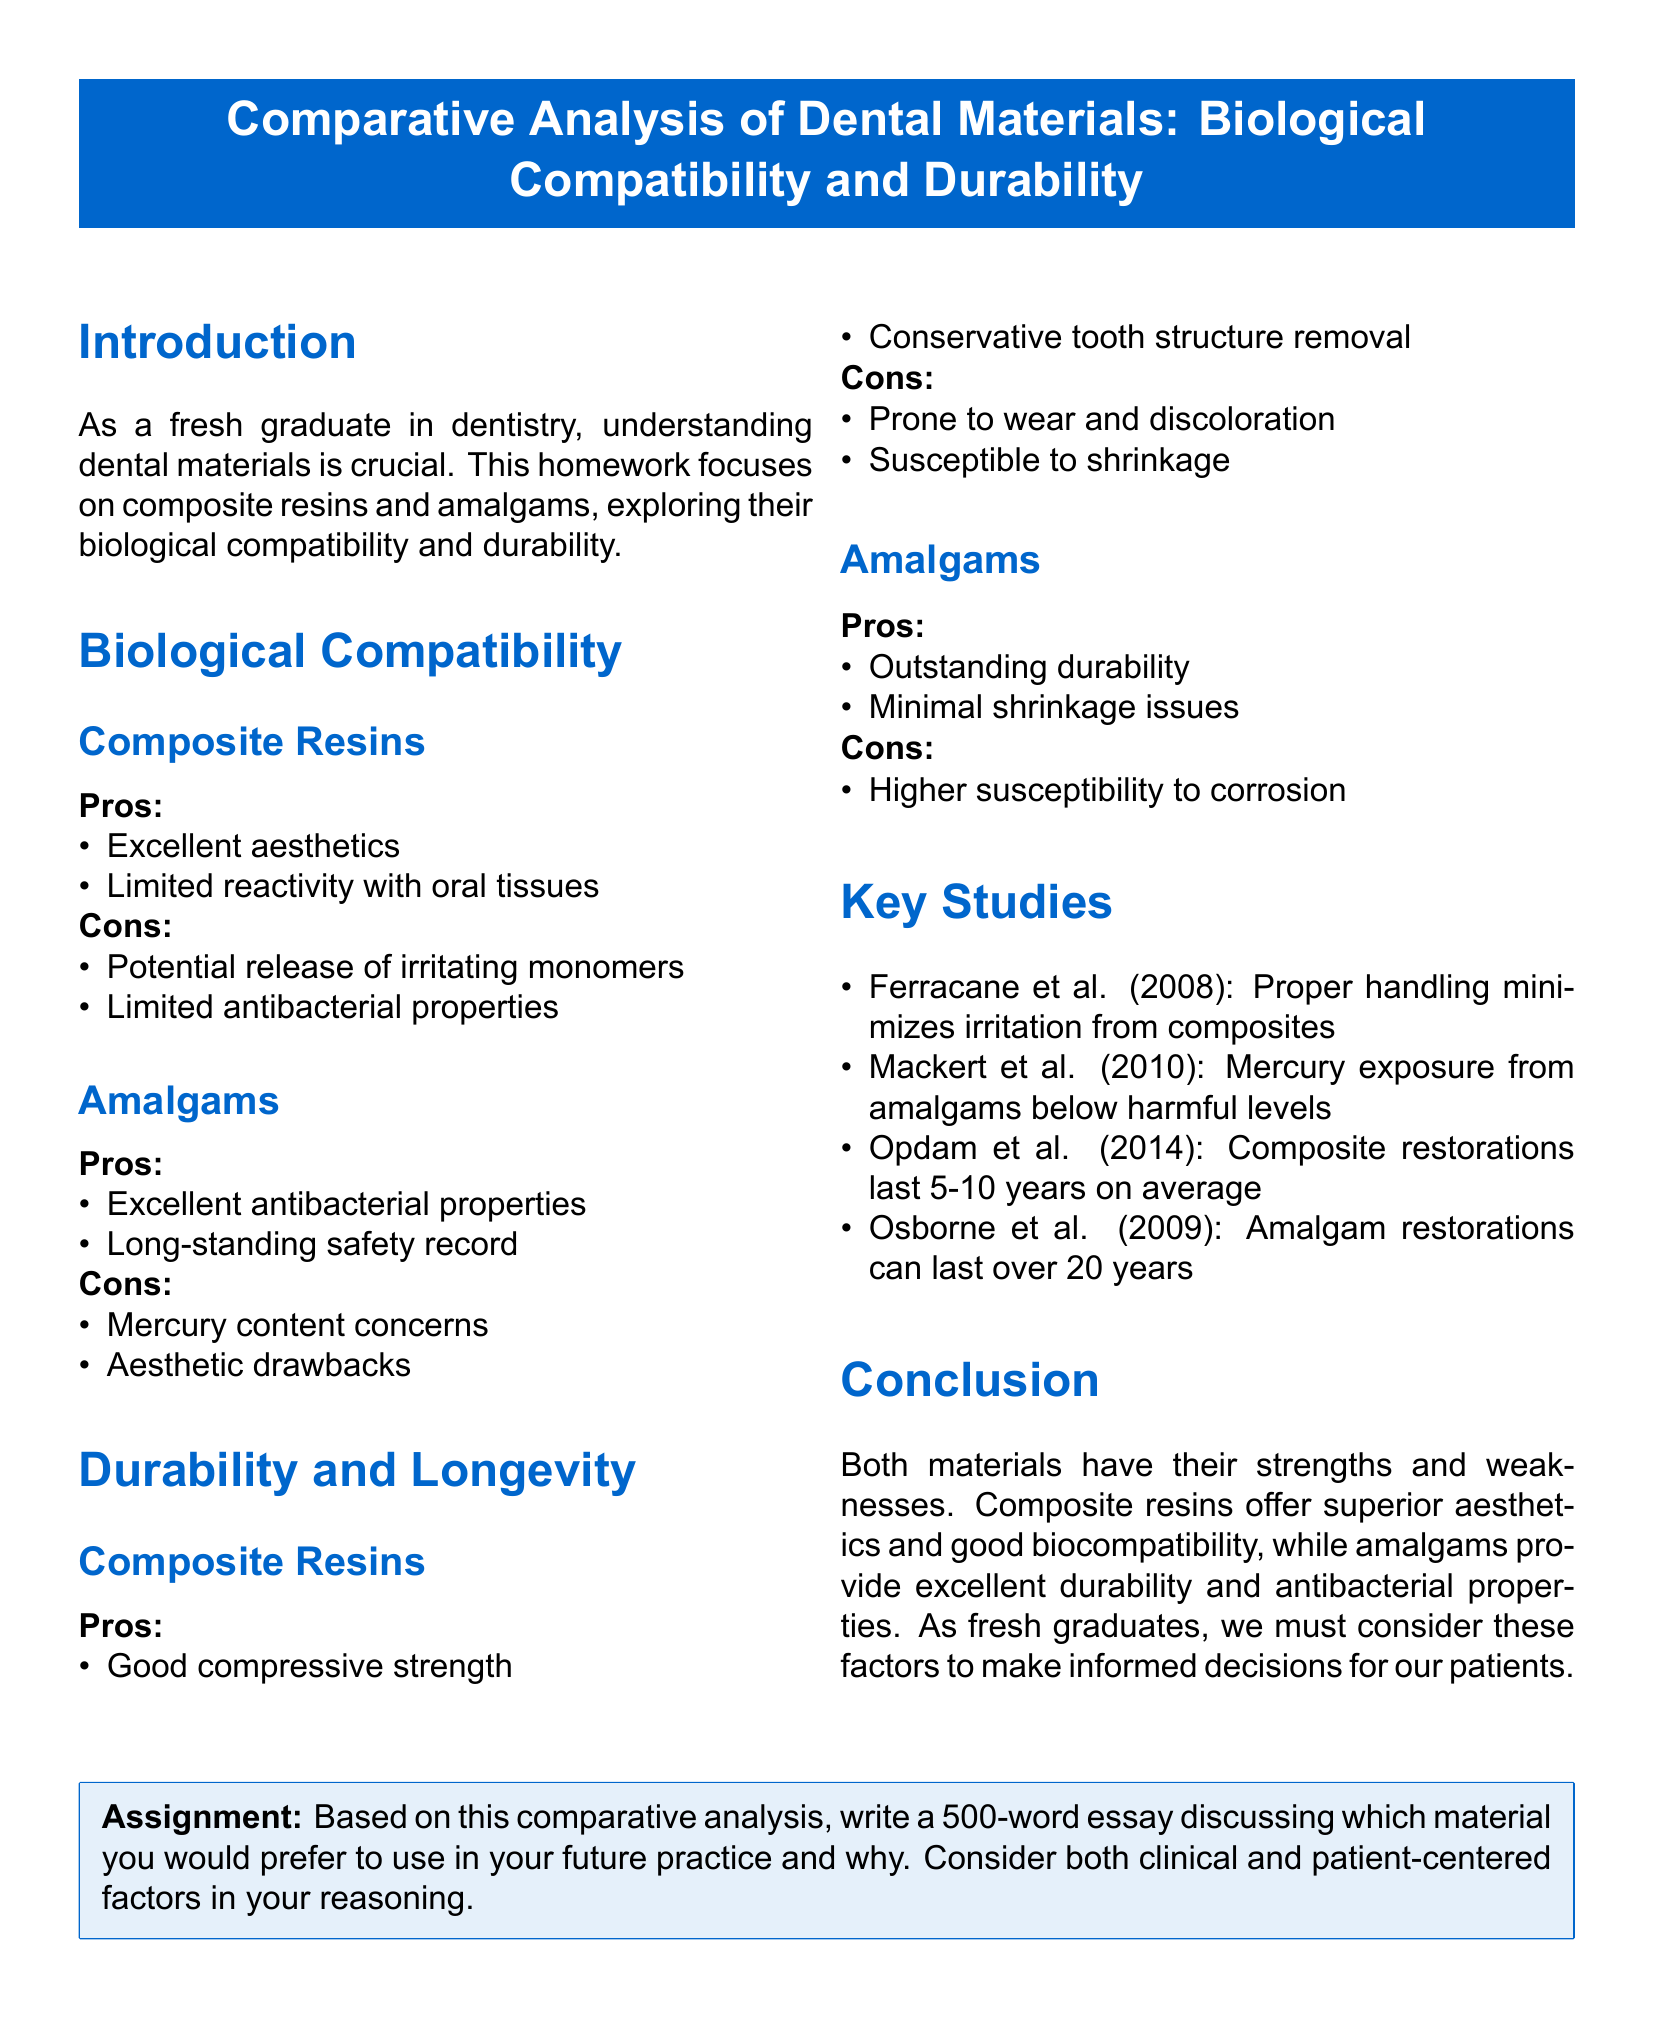What are the biological compatibility pros of composite resins? The pros of biological compatibility for composite resins include excellent aesthetics and limited reactivity with oral tissues.
Answer: Excellent aesthetics, limited reactivity What are the durability pros of amalgams? The pros of durability for amalgams include outstanding durability and minimal shrinkage issues.
Answer: Outstanding durability, minimal shrinkage How long do composite restorations typically last according to the key studies? According to Opdam et al. (2014), composite restorations last 5-10 years on average.
Answer: 5-10 years What is a con of amalgams concerning aesthetics? The aesthetic drawback is mentioned as a con for amalgams.
Answer: Aesthetic drawbacks Which study discusses the mercury exposure levels from amalgams? The study by Mackert et al. (2010) addresses mercury exposure from amalgams.
Answer: Mackert et al. (2010) What is one aesthetic advantage of composite resins? One of the pros for composite resins is excellent aesthetics.
Answer: Excellent aesthetics What is the main focus of the homework? The homework focuses on composite resins and amalgams, exploring their biological compatibility and durability.
Answer: Biological compatibility and durability Which material provides excellent antibacterial properties? Amalgams provide excellent antibacterial properties as one of their pros.
Answer: Amalgams 